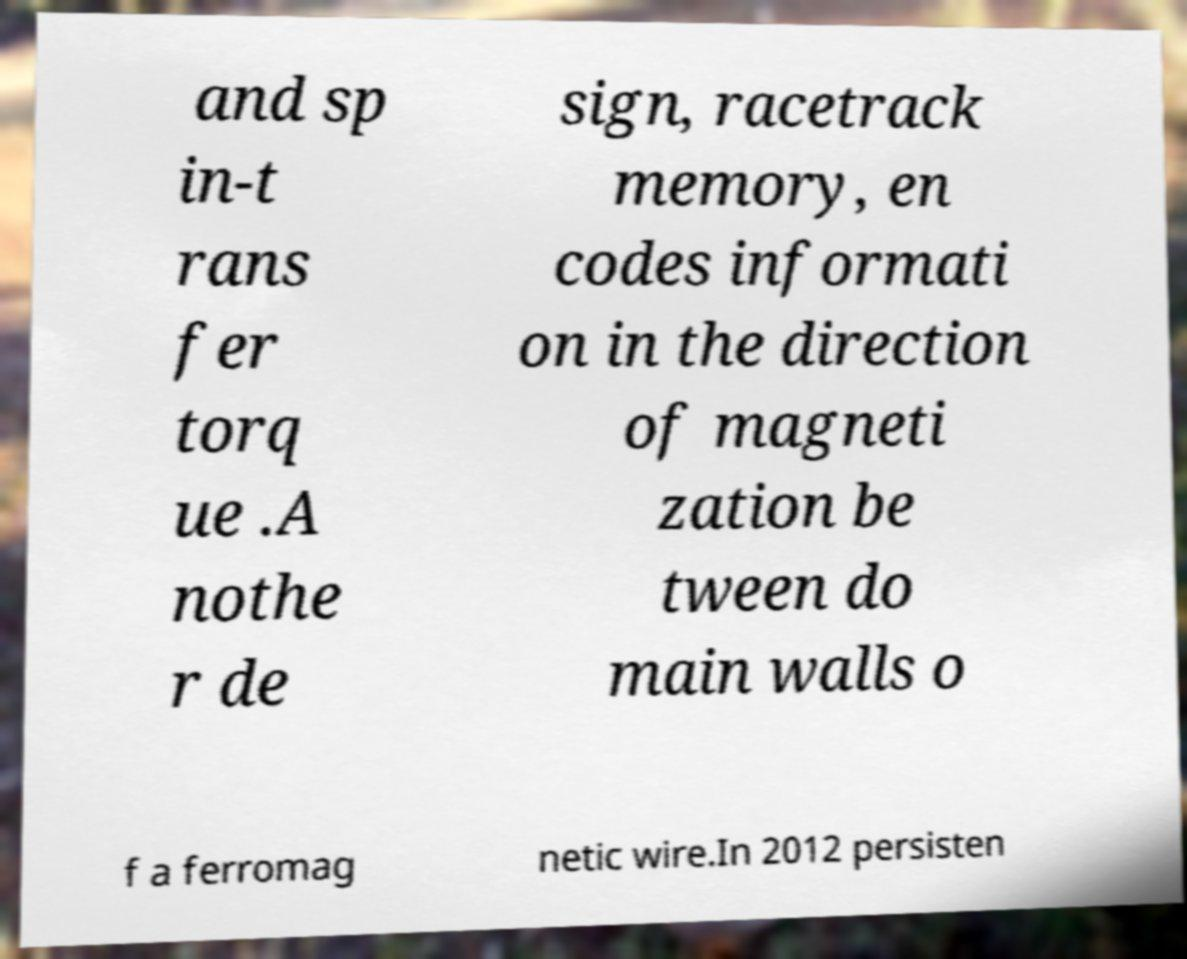Please read and relay the text visible in this image. What does it say? and sp in-t rans fer torq ue .A nothe r de sign, racetrack memory, en codes informati on in the direction of magneti zation be tween do main walls o f a ferromag netic wire.In 2012 persisten 